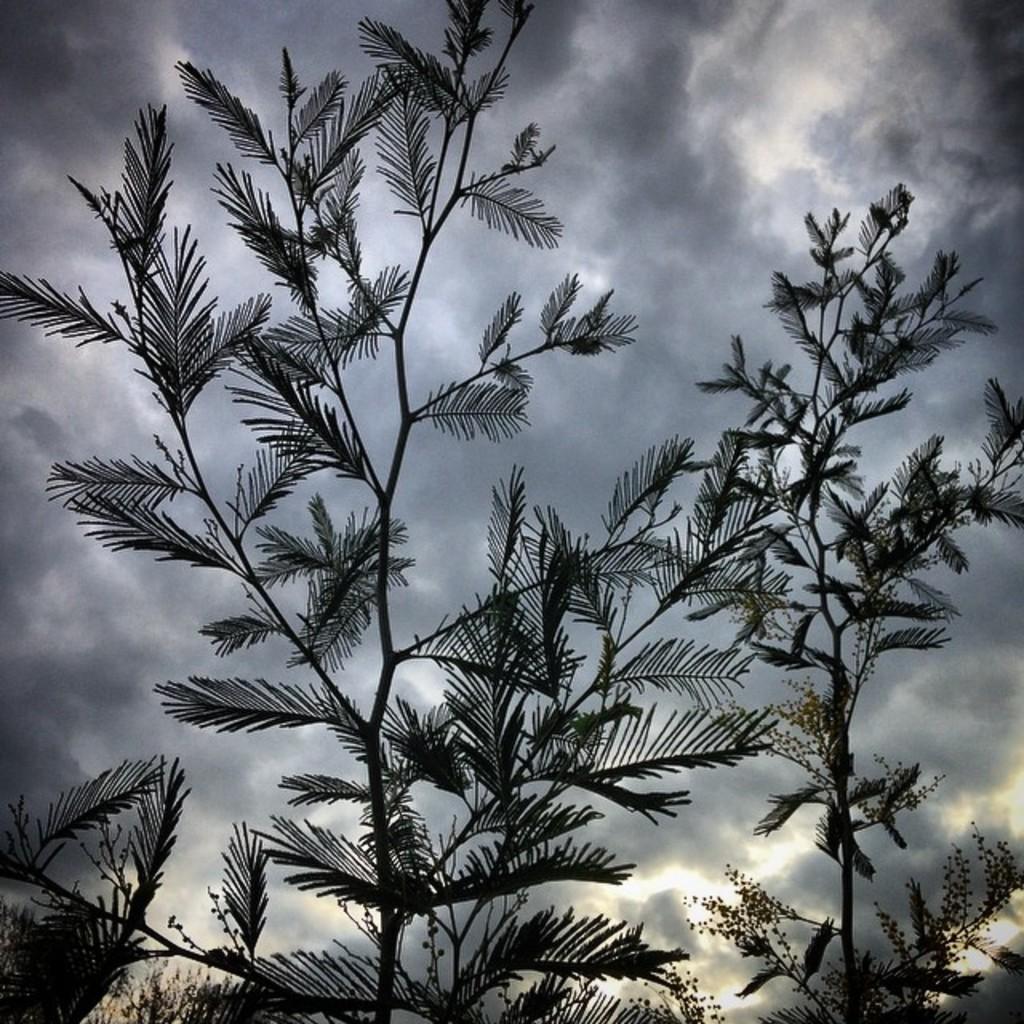Describe this image in one or two sentences. In this picture we can see trees and in the background we can see the sky with clouds. 